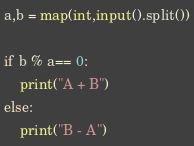Convert code to text. <code><loc_0><loc_0><loc_500><loc_500><_Python_>a,b = map(int,input().split())

if b % a== 0:
    print("A + B")
else:
    print("B - A")</code> 